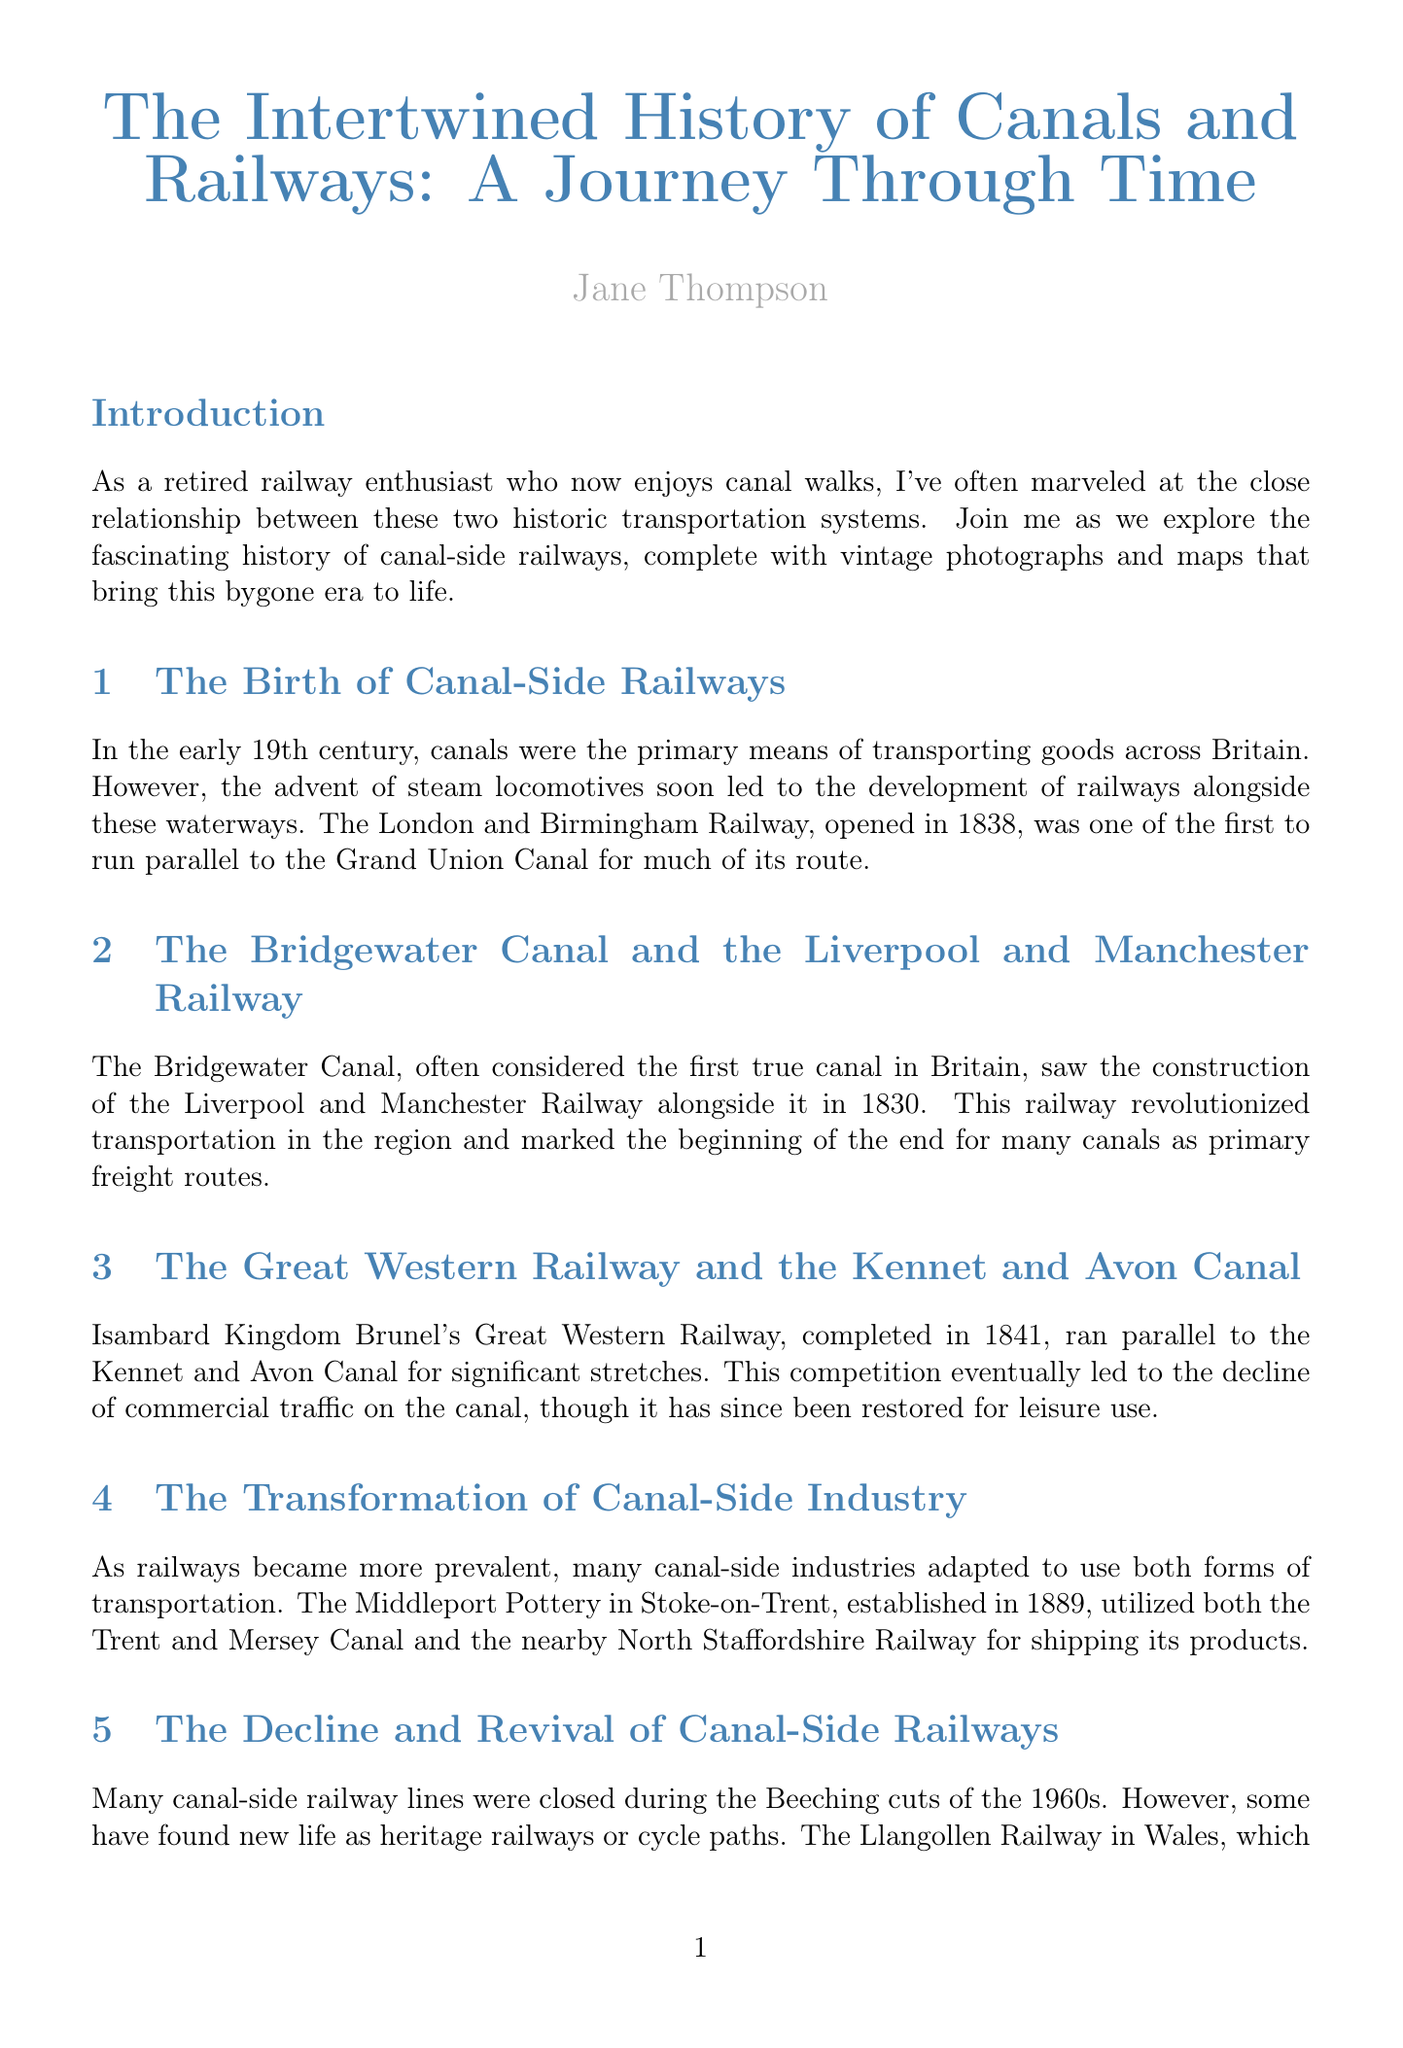What opened in 1838? The London and Birmingham Railway opened in 1838, running parallel to the Grand Union Canal.
Answer: London and Birmingham Railway Who is the author of the article? The author is a retired railway signal engineer who shares experiences and insights through her blog.
Answer: Jane Thompson What year was the Liverpool and Manchester Railway constructed? The Liverpool and Manchester Railway was constructed in 1830, along the Bridgewater Canal.
Answer: 1830 What canal runs alongside the Llangollen Railway? The Llangollen Railway runs alongside the Llangollen Canal in Wales.
Answer: Llangollen Canal What type of traffic has been restored on the Kennet and Avon Canal? The commercial traffic declined, but leisure use has been restored on the Kennet and Avon Canal.
Answer: Leisure use What significant period saw many canal-side railway lines closed? The Beeching cuts during the 1960s led to the closure of many canal-side railway lines.
Answer: 1960s Which pottery utilized both the canal and the railway? Middleport Pottery in Stoke-on-Trent utilized both the Trent and Mersey Canal and the railway.
Answer: Middleport Pottery What is the topic of the further reading recommended in the document? The further reading includes several books related to the history of canals and railways.
Answer: History of canals and railways 